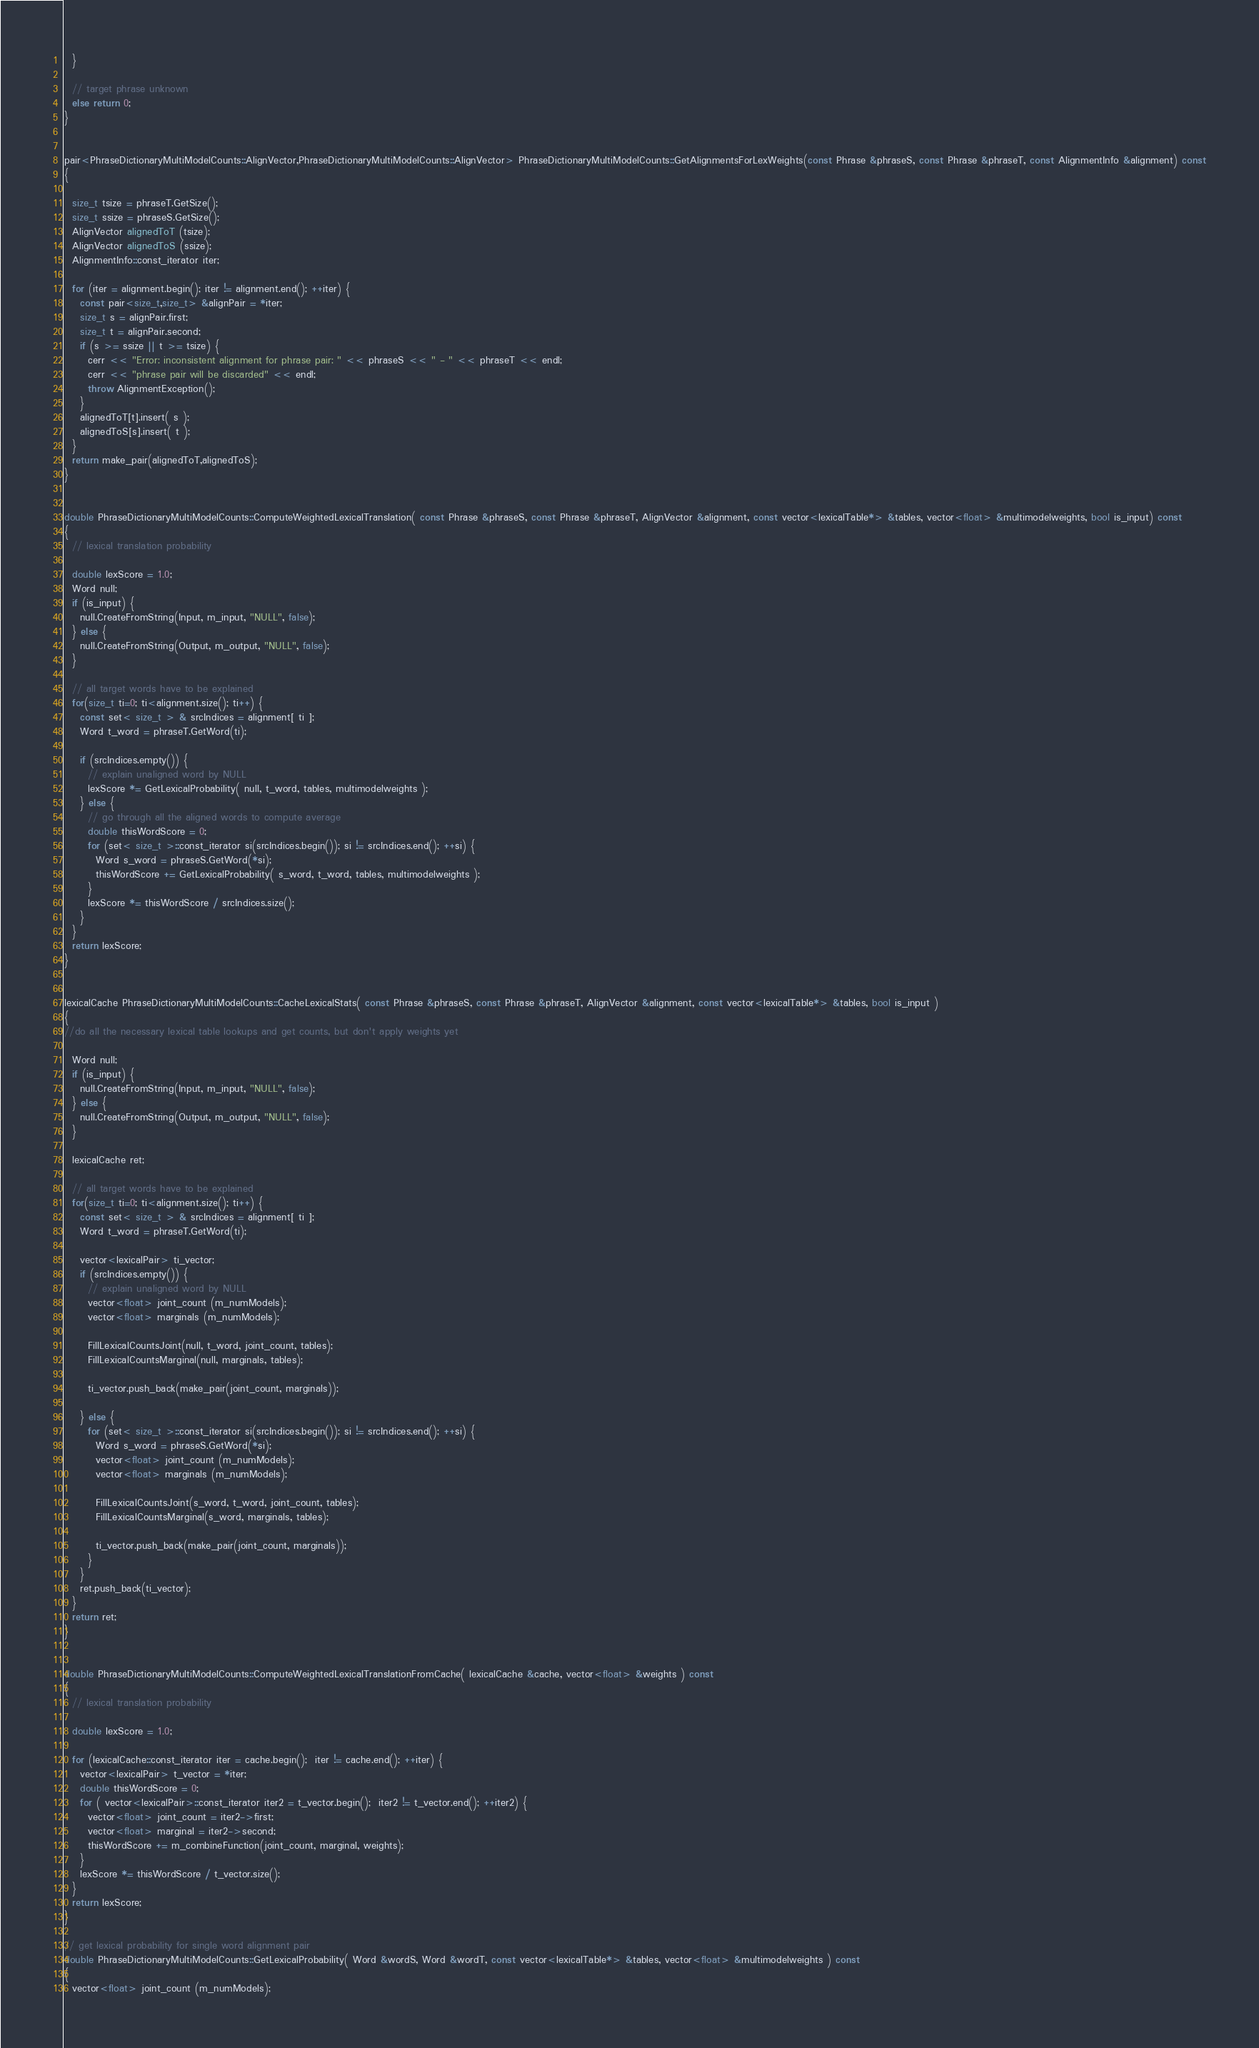Convert code to text. <code><loc_0><loc_0><loc_500><loc_500><_C++_>  }

  // target phrase unknown
  else return 0;
}


pair<PhraseDictionaryMultiModelCounts::AlignVector,PhraseDictionaryMultiModelCounts::AlignVector> PhraseDictionaryMultiModelCounts::GetAlignmentsForLexWeights(const Phrase &phraseS, const Phrase &phraseT, const AlignmentInfo &alignment) const
{

  size_t tsize = phraseT.GetSize();
  size_t ssize = phraseS.GetSize();
  AlignVector alignedToT (tsize);
  AlignVector alignedToS (ssize);
  AlignmentInfo::const_iterator iter;

  for (iter = alignment.begin(); iter != alignment.end(); ++iter) {
    const pair<size_t,size_t> &alignPair = *iter;
    size_t s = alignPair.first;
    size_t t = alignPair.second;
    if (s >= ssize || t >= tsize) {
      cerr << "Error: inconsistent alignment for phrase pair: " << phraseS << " - " << phraseT << endl;
      cerr << "phrase pair will be discarded" << endl;
      throw AlignmentException();
    }
    alignedToT[t].insert( s );
    alignedToS[s].insert( t );
  }
  return make_pair(alignedToT,alignedToS);
}


double PhraseDictionaryMultiModelCounts::ComputeWeightedLexicalTranslation( const Phrase &phraseS, const Phrase &phraseT, AlignVector &alignment, const vector<lexicalTable*> &tables, vector<float> &multimodelweights, bool is_input) const
{
  // lexical translation probability

  double lexScore = 1.0;
  Word null;
  if (is_input) {
    null.CreateFromString(Input, m_input, "NULL", false);
  } else {
    null.CreateFromString(Output, m_output, "NULL", false);
  }

  // all target words have to be explained
  for(size_t ti=0; ti<alignment.size(); ti++) {
    const set< size_t > & srcIndices = alignment[ ti ];
    Word t_word = phraseT.GetWord(ti);

    if (srcIndices.empty()) {
      // explain unaligned word by NULL
      lexScore *= GetLexicalProbability( null, t_word, tables, multimodelweights );
    } else {
      // go through all the aligned words to compute average
      double thisWordScore = 0;
      for (set< size_t >::const_iterator si(srcIndices.begin()); si != srcIndices.end(); ++si) {
        Word s_word = phraseS.GetWord(*si);
        thisWordScore += GetLexicalProbability( s_word, t_word, tables, multimodelweights );
      }
      lexScore *= thisWordScore / srcIndices.size();
    }
  }
  return lexScore;
}


lexicalCache PhraseDictionaryMultiModelCounts::CacheLexicalStats( const Phrase &phraseS, const Phrase &phraseT, AlignVector &alignment, const vector<lexicalTable*> &tables, bool is_input )
{
//do all the necessary lexical table lookups and get counts, but don't apply weights yet

  Word null;
  if (is_input) {
    null.CreateFromString(Input, m_input, "NULL", false);
  } else {
    null.CreateFromString(Output, m_output, "NULL", false);
  }

  lexicalCache ret;

  // all target words have to be explained
  for(size_t ti=0; ti<alignment.size(); ti++) {
    const set< size_t > & srcIndices = alignment[ ti ];
    Word t_word = phraseT.GetWord(ti);

    vector<lexicalPair> ti_vector;
    if (srcIndices.empty()) {
      // explain unaligned word by NULL
      vector<float> joint_count (m_numModels);
      vector<float> marginals (m_numModels);

      FillLexicalCountsJoint(null, t_word, joint_count, tables);
      FillLexicalCountsMarginal(null, marginals, tables);

      ti_vector.push_back(make_pair(joint_count, marginals));

    } else {
      for (set< size_t >::const_iterator si(srcIndices.begin()); si != srcIndices.end(); ++si) {
        Word s_word = phraseS.GetWord(*si);
        vector<float> joint_count (m_numModels);
        vector<float> marginals (m_numModels);

        FillLexicalCountsJoint(s_word, t_word, joint_count, tables);
        FillLexicalCountsMarginal(s_word, marginals, tables);

        ti_vector.push_back(make_pair(joint_count, marginals));
      }
    }
    ret.push_back(ti_vector);
  }
  return ret;
}


double PhraseDictionaryMultiModelCounts::ComputeWeightedLexicalTranslationFromCache( lexicalCache &cache, vector<float> &weights ) const
{
  // lexical translation probability

  double lexScore = 1.0;

  for (lexicalCache::const_iterator iter = cache.begin();  iter != cache.end(); ++iter) {
    vector<lexicalPair> t_vector = *iter;
    double thisWordScore = 0;
    for ( vector<lexicalPair>::const_iterator iter2 = t_vector.begin();  iter2 != t_vector.end(); ++iter2) {
      vector<float> joint_count = iter2->first;
      vector<float> marginal = iter2->second;
      thisWordScore += m_combineFunction(joint_count, marginal, weights);
    }
    lexScore *= thisWordScore / t_vector.size();
  }
  return lexScore;
}

// get lexical probability for single word alignment pair
double PhraseDictionaryMultiModelCounts::GetLexicalProbability( Word &wordS, Word &wordT, const vector<lexicalTable*> &tables, vector<float> &multimodelweights ) const
{
  vector<float> joint_count (m_numModels);</code> 